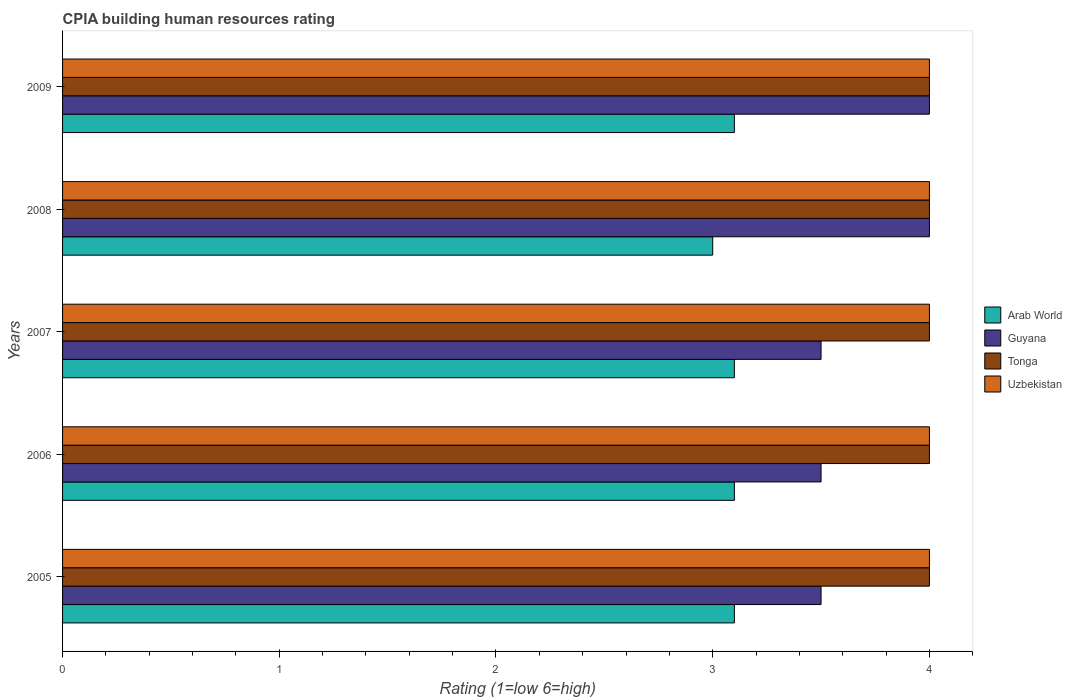How many different coloured bars are there?
Your answer should be compact. 4. Are the number of bars on each tick of the Y-axis equal?
Your answer should be very brief. Yes. How many bars are there on the 5th tick from the top?
Your answer should be compact. 4. How many bars are there on the 1st tick from the bottom?
Offer a very short reply. 4. What is the label of the 4th group of bars from the top?
Make the answer very short. 2006. What is the CPIA rating in Tonga in 2008?
Your answer should be very brief. 4. Across all years, what is the maximum CPIA rating in Arab World?
Your answer should be very brief. 3.1. Across all years, what is the minimum CPIA rating in Tonga?
Offer a very short reply. 4. In which year was the CPIA rating in Arab World maximum?
Make the answer very short. 2005. What is the total CPIA rating in Guyana in the graph?
Give a very brief answer. 18.5. What is the difference between the CPIA rating in Uzbekistan in 2006 and the CPIA rating in Arab World in 2005?
Your response must be concise. 0.9. What is the average CPIA rating in Guyana per year?
Ensure brevity in your answer.  3.7. In the year 2005, what is the difference between the CPIA rating in Tonga and CPIA rating in Uzbekistan?
Make the answer very short. 0. What is the ratio of the CPIA rating in Guyana in 2007 to that in 2009?
Provide a succinct answer. 0.88. Is the CPIA rating in Arab World in 2005 less than that in 2009?
Offer a very short reply. No. What is the difference between the highest and the second highest CPIA rating in Guyana?
Give a very brief answer. 0. What is the difference between the highest and the lowest CPIA rating in Arab World?
Your answer should be very brief. 0.1. Is the sum of the CPIA rating in Arab World in 2008 and 2009 greater than the maximum CPIA rating in Tonga across all years?
Give a very brief answer. Yes. What does the 4th bar from the top in 2005 represents?
Ensure brevity in your answer.  Arab World. What does the 4th bar from the bottom in 2009 represents?
Offer a very short reply. Uzbekistan. Is it the case that in every year, the sum of the CPIA rating in Arab World and CPIA rating in Guyana is greater than the CPIA rating in Tonga?
Make the answer very short. Yes. Are all the bars in the graph horizontal?
Make the answer very short. Yes. How many years are there in the graph?
Offer a very short reply. 5. What is the difference between two consecutive major ticks on the X-axis?
Offer a terse response. 1. Does the graph contain grids?
Provide a succinct answer. No. How many legend labels are there?
Ensure brevity in your answer.  4. What is the title of the graph?
Offer a very short reply. CPIA building human resources rating. What is the label or title of the X-axis?
Ensure brevity in your answer.  Rating (1=low 6=high). What is the Rating (1=low 6=high) of Arab World in 2005?
Provide a short and direct response. 3.1. What is the Rating (1=low 6=high) of Guyana in 2005?
Provide a short and direct response. 3.5. What is the Rating (1=low 6=high) of Uzbekistan in 2005?
Your answer should be very brief. 4. What is the Rating (1=low 6=high) of Arab World in 2006?
Ensure brevity in your answer.  3.1. What is the Rating (1=low 6=high) of Guyana in 2006?
Your response must be concise. 3.5. What is the Rating (1=low 6=high) in Tonga in 2006?
Provide a short and direct response. 4. What is the Rating (1=low 6=high) of Uzbekistan in 2006?
Offer a very short reply. 4. What is the Rating (1=low 6=high) of Uzbekistan in 2007?
Make the answer very short. 4. What is the Rating (1=low 6=high) in Arab World in 2008?
Make the answer very short. 3. What is the Rating (1=low 6=high) in Guyana in 2008?
Keep it short and to the point. 4. What is the Rating (1=low 6=high) of Uzbekistan in 2008?
Ensure brevity in your answer.  4. What is the Rating (1=low 6=high) of Arab World in 2009?
Ensure brevity in your answer.  3.1. Across all years, what is the maximum Rating (1=low 6=high) in Tonga?
Your answer should be compact. 4. Across all years, what is the maximum Rating (1=low 6=high) of Uzbekistan?
Your response must be concise. 4. Across all years, what is the minimum Rating (1=low 6=high) of Arab World?
Provide a short and direct response. 3. Across all years, what is the minimum Rating (1=low 6=high) in Tonga?
Keep it short and to the point. 4. Across all years, what is the minimum Rating (1=low 6=high) in Uzbekistan?
Provide a short and direct response. 4. What is the total Rating (1=low 6=high) in Arab World in the graph?
Your response must be concise. 15.4. What is the total Rating (1=low 6=high) in Tonga in the graph?
Ensure brevity in your answer.  20. What is the total Rating (1=low 6=high) in Uzbekistan in the graph?
Provide a succinct answer. 20. What is the difference between the Rating (1=low 6=high) in Arab World in 2005 and that in 2006?
Ensure brevity in your answer.  0. What is the difference between the Rating (1=low 6=high) in Guyana in 2005 and that in 2006?
Your answer should be very brief. 0. What is the difference between the Rating (1=low 6=high) of Uzbekistan in 2005 and that in 2006?
Provide a short and direct response. 0. What is the difference between the Rating (1=low 6=high) in Arab World in 2005 and that in 2007?
Give a very brief answer. 0. What is the difference between the Rating (1=low 6=high) in Guyana in 2005 and that in 2007?
Your response must be concise. 0. What is the difference between the Rating (1=low 6=high) in Tonga in 2005 and that in 2007?
Ensure brevity in your answer.  0. What is the difference between the Rating (1=low 6=high) in Arab World in 2005 and that in 2008?
Offer a terse response. 0.1. What is the difference between the Rating (1=low 6=high) in Guyana in 2005 and that in 2008?
Offer a terse response. -0.5. What is the difference between the Rating (1=low 6=high) of Uzbekistan in 2005 and that in 2008?
Your response must be concise. 0. What is the difference between the Rating (1=low 6=high) of Arab World in 2005 and that in 2009?
Keep it short and to the point. 0. What is the difference between the Rating (1=low 6=high) in Guyana in 2005 and that in 2009?
Your response must be concise. -0.5. What is the difference between the Rating (1=low 6=high) in Uzbekistan in 2005 and that in 2009?
Your response must be concise. 0. What is the difference between the Rating (1=low 6=high) of Guyana in 2006 and that in 2007?
Your response must be concise. 0. What is the difference between the Rating (1=low 6=high) of Tonga in 2006 and that in 2007?
Your answer should be compact. 0. What is the difference between the Rating (1=low 6=high) in Guyana in 2006 and that in 2008?
Your answer should be compact. -0.5. What is the difference between the Rating (1=low 6=high) of Tonga in 2006 and that in 2008?
Provide a succinct answer. 0. What is the difference between the Rating (1=low 6=high) in Uzbekistan in 2006 and that in 2008?
Give a very brief answer. 0. What is the difference between the Rating (1=low 6=high) in Arab World in 2006 and that in 2009?
Make the answer very short. 0. What is the difference between the Rating (1=low 6=high) of Tonga in 2006 and that in 2009?
Ensure brevity in your answer.  0. What is the difference between the Rating (1=low 6=high) in Arab World in 2007 and that in 2008?
Your response must be concise. 0.1. What is the difference between the Rating (1=low 6=high) of Guyana in 2007 and that in 2008?
Make the answer very short. -0.5. What is the difference between the Rating (1=low 6=high) in Guyana in 2007 and that in 2009?
Offer a very short reply. -0.5. What is the difference between the Rating (1=low 6=high) in Uzbekistan in 2007 and that in 2009?
Your answer should be very brief. 0. What is the difference between the Rating (1=low 6=high) in Guyana in 2008 and that in 2009?
Keep it short and to the point. 0. What is the difference between the Rating (1=low 6=high) in Uzbekistan in 2008 and that in 2009?
Offer a terse response. 0. What is the difference between the Rating (1=low 6=high) of Arab World in 2005 and the Rating (1=low 6=high) of Tonga in 2006?
Your response must be concise. -0.9. What is the difference between the Rating (1=low 6=high) of Tonga in 2005 and the Rating (1=low 6=high) of Uzbekistan in 2006?
Offer a terse response. 0. What is the difference between the Rating (1=low 6=high) in Guyana in 2005 and the Rating (1=low 6=high) in Tonga in 2007?
Provide a short and direct response. -0.5. What is the difference between the Rating (1=low 6=high) of Tonga in 2005 and the Rating (1=low 6=high) of Uzbekistan in 2007?
Ensure brevity in your answer.  0. What is the difference between the Rating (1=low 6=high) in Arab World in 2005 and the Rating (1=low 6=high) in Guyana in 2008?
Keep it short and to the point. -0.9. What is the difference between the Rating (1=low 6=high) of Guyana in 2005 and the Rating (1=low 6=high) of Tonga in 2008?
Keep it short and to the point. -0.5. What is the difference between the Rating (1=low 6=high) in Tonga in 2005 and the Rating (1=low 6=high) in Uzbekistan in 2008?
Your answer should be very brief. 0. What is the difference between the Rating (1=low 6=high) of Arab World in 2005 and the Rating (1=low 6=high) of Guyana in 2009?
Your answer should be compact. -0.9. What is the difference between the Rating (1=low 6=high) in Arab World in 2005 and the Rating (1=low 6=high) in Tonga in 2009?
Your response must be concise. -0.9. What is the difference between the Rating (1=low 6=high) in Tonga in 2005 and the Rating (1=low 6=high) in Uzbekistan in 2009?
Your answer should be very brief. 0. What is the difference between the Rating (1=low 6=high) of Arab World in 2006 and the Rating (1=low 6=high) of Uzbekistan in 2007?
Ensure brevity in your answer.  -0.9. What is the difference between the Rating (1=low 6=high) of Tonga in 2006 and the Rating (1=low 6=high) of Uzbekistan in 2007?
Your answer should be very brief. 0. What is the difference between the Rating (1=low 6=high) in Arab World in 2006 and the Rating (1=low 6=high) in Guyana in 2008?
Your response must be concise. -0.9. What is the difference between the Rating (1=low 6=high) of Arab World in 2006 and the Rating (1=low 6=high) of Uzbekistan in 2008?
Ensure brevity in your answer.  -0.9. What is the difference between the Rating (1=low 6=high) of Guyana in 2006 and the Rating (1=low 6=high) of Tonga in 2008?
Make the answer very short. -0.5. What is the difference between the Rating (1=low 6=high) of Guyana in 2006 and the Rating (1=low 6=high) of Uzbekistan in 2008?
Offer a terse response. -0.5. What is the difference between the Rating (1=low 6=high) of Tonga in 2006 and the Rating (1=low 6=high) of Uzbekistan in 2008?
Your answer should be compact. 0. What is the difference between the Rating (1=low 6=high) of Arab World in 2006 and the Rating (1=low 6=high) of Guyana in 2009?
Offer a very short reply. -0.9. What is the difference between the Rating (1=low 6=high) of Arab World in 2006 and the Rating (1=low 6=high) of Tonga in 2009?
Give a very brief answer. -0.9. What is the difference between the Rating (1=low 6=high) in Guyana in 2007 and the Rating (1=low 6=high) in Tonga in 2008?
Keep it short and to the point. -0.5. What is the difference between the Rating (1=low 6=high) in Guyana in 2007 and the Rating (1=low 6=high) in Uzbekistan in 2008?
Your response must be concise. -0.5. What is the difference between the Rating (1=low 6=high) in Arab World in 2007 and the Rating (1=low 6=high) in Guyana in 2009?
Make the answer very short. -0.9. What is the difference between the Rating (1=low 6=high) in Guyana in 2007 and the Rating (1=low 6=high) in Uzbekistan in 2009?
Keep it short and to the point. -0.5. What is the difference between the Rating (1=low 6=high) in Tonga in 2007 and the Rating (1=low 6=high) in Uzbekistan in 2009?
Provide a succinct answer. 0. What is the difference between the Rating (1=low 6=high) of Guyana in 2008 and the Rating (1=low 6=high) of Tonga in 2009?
Provide a short and direct response. 0. What is the average Rating (1=low 6=high) of Arab World per year?
Your response must be concise. 3.08. What is the average Rating (1=low 6=high) in Tonga per year?
Offer a terse response. 4. In the year 2005, what is the difference between the Rating (1=low 6=high) of Arab World and Rating (1=low 6=high) of Tonga?
Make the answer very short. -0.9. In the year 2006, what is the difference between the Rating (1=low 6=high) in Arab World and Rating (1=low 6=high) in Guyana?
Keep it short and to the point. -0.4. In the year 2006, what is the difference between the Rating (1=low 6=high) in Guyana and Rating (1=low 6=high) in Tonga?
Ensure brevity in your answer.  -0.5. In the year 2006, what is the difference between the Rating (1=low 6=high) in Tonga and Rating (1=low 6=high) in Uzbekistan?
Make the answer very short. 0. In the year 2007, what is the difference between the Rating (1=low 6=high) in Arab World and Rating (1=low 6=high) in Tonga?
Your response must be concise. -0.9. In the year 2007, what is the difference between the Rating (1=low 6=high) of Arab World and Rating (1=low 6=high) of Uzbekistan?
Give a very brief answer. -0.9. In the year 2007, what is the difference between the Rating (1=low 6=high) in Guyana and Rating (1=low 6=high) in Tonga?
Provide a succinct answer. -0.5. In the year 2007, what is the difference between the Rating (1=low 6=high) of Guyana and Rating (1=low 6=high) of Uzbekistan?
Make the answer very short. -0.5. In the year 2008, what is the difference between the Rating (1=low 6=high) of Arab World and Rating (1=low 6=high) of Guyana?
Your answer should be compact. -1. In the year 2008, what is the difference between the Rating (1=low 6=high) of Arab World and Rating (1=low 6=high) of Tonga?
Offer a terse response. -1. In the year 2008, what is the difference between the Rating (1=low 6=high) of Arab World and Rating (1=low 6=high) of Uzbekistan?
Make the answer very short. -1. In the year 2008, what is the difference between the Rating (1=low 6=high) in Tonga and Rating (1=low 6=high) in Uzbekistan?
Ensure brevity in your answer.  0. In the year 2009, what is the difference between the Rating (1=low 6=high) of Arab World and Rating (1=low 6=high) of Guyana?
Your answer should be compact. -0.9. In the year 2009, what is the difference between the Rating (1=low 6=high) of Arab World and Rating (1=low 6=high) of Tonga?
Provide a short and direct response. -0.9. In the year 2009, what is the difference between the Rating (1=low 6=high) of Guyana and Rating (1=low 6=high) of Uzbekistan?
Your response must be concise. 0. In the year 2009, what is the difference between the Rating (1=low 6=high) in Tonga and Rating (1=low 6=high) in Uzbekistan?
Ensure brevity in your answer.  0. What is the ratio of the Rating (1=low 6=high) in Guyana in 2005 to that in 2006?
Your response must be concise. 1. What is the ratio of the Rating (1=low 6=high) of Tonga in 2005 to that in 2006?
Give a very brief answer. 1. What is the ratio of the Rating (1=low 6=high) of Arab World in 2005 to that in 2007?
Your answer should be very brief. 1. What is the ratio of the Rating (1=low 6=high) of Guyana in 2005 to that in 2007?
Give a very brief answer. 1. What is the ratio of the Rating (1=low 6=high) of Uzbekistan in 2005 to that in 2007?
Offer a terse response. 1. What is the ratio of the Rating (1=low 6=high) of Arab World in 2005 to that in 2008?
Make the answer very short. 1.03. What is the ratio of the Rating (1=low 6=high) in Uzbekistan in 2005 to that in 2008?
Give a very brief answer. 1. What is the ratio of the Rating (1=low 6=high) of Tonga in 2005 to that in 2009?
Make the answer very short. 1. What is the ratio of the Rating (1=low 6=high) of Guyana in 2006 to that in 2008?
Offer a very short reply. 0.88. What is the ratio of the Rating (1=low 6=high) of Tonga in 2006 to that in 2008?
Your answer should be very brief. 1. What is the ratio of the Rating (1=low 6=high) of Arab World in 2006 to that in 2009?
Ensure brevity in your answer.  1. What is the ratio of the Rating (1=low 6=high) in Guyana in 2006 to that in 2009?
Provide a short and direct response. 0.88. What is the ratio of the Rating (1=low 6=high) in Tonga in 2006 to that in 2009?
Ensure brevity in your answer.  1. What is the ratio of the Rating (1=low 6=high) in Guyana in 2007 to that in 2008?
Your answer should be compact. 0.88. What is the ratio of the Rating (1=low 6=high) in Tonga in 2007 to that in 2008?
Give a very brief answer. 1. What is the ratio of the Rating (1=low 6=high) of Uzbekistan in 2007 to that in 2008?
Your response must be concise. 1. What is the ratio of the Rating (1=low 6=high) of Tonga in 2007 to that in 2009?
Make the answer very short. 1. What is the ratio of the Rating (1=low 6=high) of Uzbekistan in 2007 to that in 2009?
Your response must be concise. 1. What is the ratio of the Rating (1=low 6=high) of Guyana in 2008 to that in 2009?
Your answer should be very brief. 1. What is the difference between the highest and the second highest Rating (1=low 6=high) of Guyana?
Keep it short and to the point. 0. What is the difference between the highest and the lowest Rating (1=low 6=high) in Arab World?
Provide a short and direct response. 0.1. What is the difference between the highest and the lowest Rating (1=low 6=high) in Tonga?
Offer a terse response. 0. What is the difference between the highest and the lowest Rating (1=low 6=high) in Uzbekistan?
Your answer should be very brief. 0. 